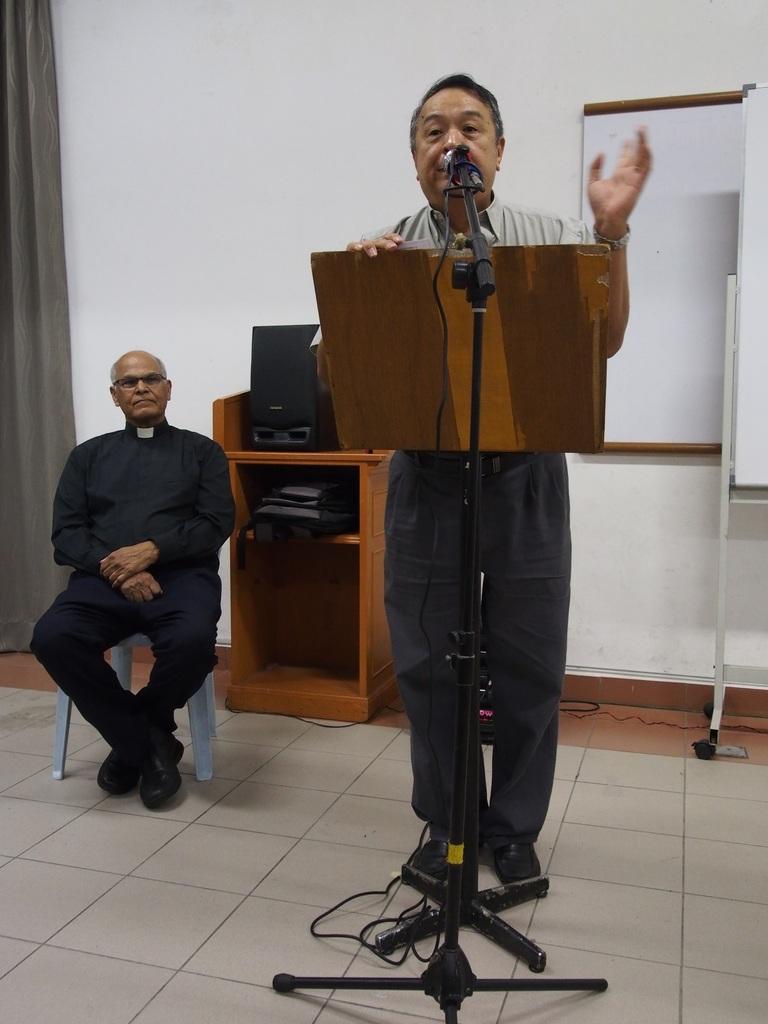Describe this image in one or two sentences. In this image can see this person wearing shirt is standing near the mic, which is kept to the stand and here we can see this person is sitting on the chair. In the background, we can see speakers and a backpack are kept on the podium, we can see the boards and curtains on the wall. 